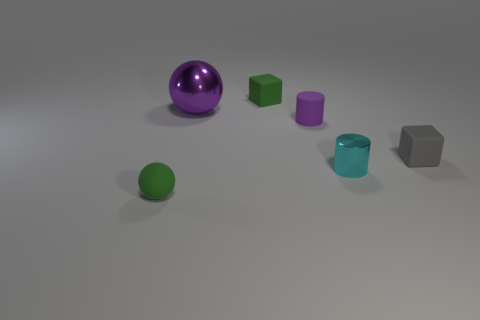There is a thing that is the same color as the matte cylinder; what material is it?
Give a very brief answer. Metal. What is the color of the tiny rubber cube that is on the left side of the small block that is in front of the block that is on the left side of the small gray object?
Your response must be concise. Green. How many matte objects are purple spheres or brown cylinders?
Ensure brevity in your answer.  0. Is the cyan shiny thing the same size as the purple cylinder?
Make the answer very short. Yes. Is the number of small purple rubber objects that are on the left side of the large purple ball less than the number of tiny green rubber things to the right of the green sphere?
Your answer should be very brief. Yes. Is there any other thing that is the same size as the purple sphere?
Keep it short and to the point. No. What size is the metal ball?
Provide a succinct answer. Large. How many large objects are purple rubber balls or purple rubber things?
Offer a terse response. 0. There is a purple metallic object; is it the same size as the green object that is in front of the purple ball?
Provide a short and direct response. No. How many cyan objects are there?
Provide a succinct answer. 1. 